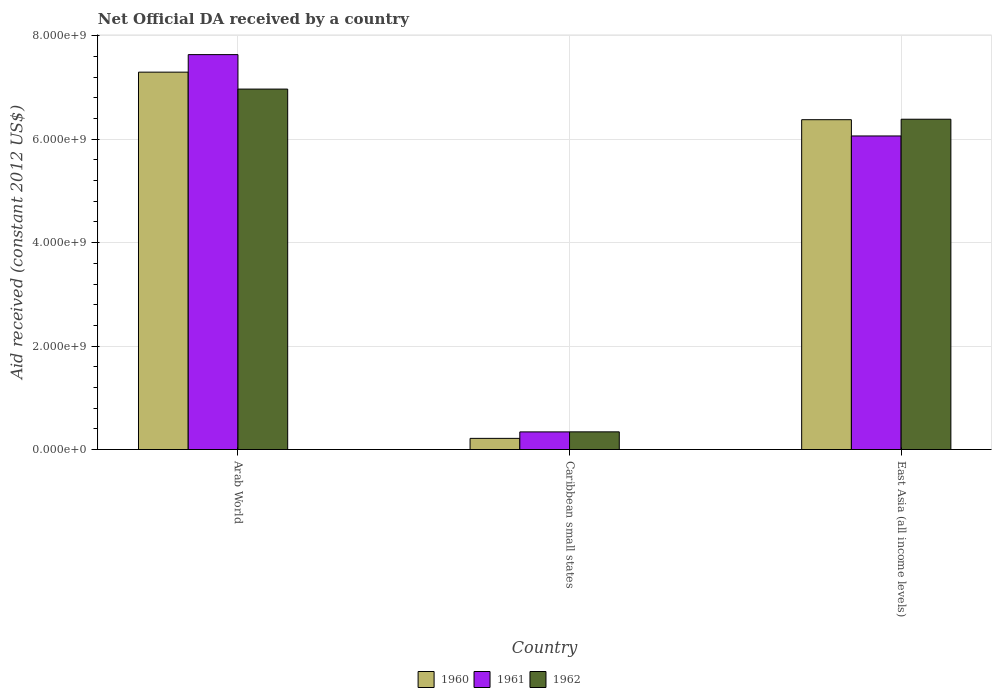How many different coloured bars are there?
Give a very brief answer. 3. Are the number of bars on each tick of the X-axis equal?
Offer a very short reply. Yes. How many bars are there on the 3rd tick from the left?
Provide a succinct answer. 3. How many bars are there on the 1st tick from the right?
Your answer should be very brief. 3. What is the label of the 3rd group of bars from the left?
Your answer should be compact. East Asia (all income levels). In how many cases, is the number of bars for a given country not equal to the number of legend labels?
Provide a succinct answer. 0. What is the net official development assistance aid received in 1960 in East Asia (all income levels)?
Your answer should be very brief. 6.38e+09. Across all countries, what is the maximum net official development assistance aid received in 1960?
Your answer should be very brief. 7.30e+09. Across all countries, what is the minimum net official development assistance aid received in 1960?
Offer a very short reply. 2.15e+08. In which country was the net official development assistance aid received in 1960 maximum?
Give a very brief answer. Arab World. In which country was the net official development assistance aid received in 1962 minimum?
Offer a very short reply. Caribbean small states. What is the total net official development assistance aid received in 1961 in the graph?
Provide a succinct answer. 1.40e+1. What is the difference between the net official development assistance aid received in 1962 in Caribbean small states and that in East Asia (all income levels)?
Your response must be concise. -6.04e+09. What is the difference between the net official development assistance aid received in 1960 in East Asia (all income levels) and the net official development assistance aid received in 1961 in Caribbean small states?
Make the answer very short. 6.04e+09. What is the average net official development assistance aid received in 1961 per country?
Keep it short and to the point. 4.68e+09. What is the difference between the net official development assistance aid received of/in 1961 and net official development assistance aid received of/in 1960 in East Asia (all income levels)?
Make the answer very short. -3.14e+08. What is the ratio of the net official development assistance aid received in 1962 in Caribbean small states to that in East Asia (all income levels)?
Your answer should be very brief. 0.05. Is the difference between the net official development assistance aid received in 1961 in Arab World and East Asia (all income levels) greater than the difference between the net official development assistance aid received in 1960 in Arab World and East Asia (all income levels)?
Ensure brevity in your answer.  Yes. What is the difference between the highest and the second highest net official development assistance aid received in 1961?
Give a very brief answer. 7.29e+09. What is the difference between the highest and the lowest net official development assistance aid received in 1960?
Give a very brief answer. 7.08e+09. Is the sum of the net official development assistance aid received in 1960 in Arab World and East Asia (all income levels) greater than the maximum net official development assistance aid received in 1961 across all countries?
Your response must be concise. Yes. What does the 3rd bar from the left in East Asia (all income levels) represents?
Offer a very short reply. 1962. What does the 2nd bar from the right in East Asia (all income levels) represents?
Offer a terse response. 1961. Is it the case that in every country, the sum of the net official development assistance aid received in 1962 and net official development assistance aid received in 1960 is greater than the net official development assistance aid received in 1961?
Offer a terse response. Yes. Are the values on the major ticks of Y-axis written in scientific E-notation?
Make the answer very short. Yes. Does the graph contain grids?
Keep it short and to the point. Yes. How many legend labels are there?
Keep it short and to the point. 3. How are the legend labels stacked?
Your response must be concise. Horizontal. What is the title of the graph?
Your answer should be compact. Net Official DA received by a country. What is the label or title of the Y-axis?
Offer a terse response. Aid received (constant 2012 US$). What is the Aid received (constant 2012 US$) of 1960 in Arab World?
Offer a very short reply. 7.30e+09. What is the Aid received (constant 2012 US$) of 1961 in Arab World?
Your answer should be very brief. 7.64e+09. What is the Aid received (constant 2012 US$) of 1962 in Arab World?
Ensure brevity in your answer.  6.97e+09. What is the Aid received (constant 2012 US$) of 1960 in Caribbean small states?
Offer a very short reply. 2.15e+08. What is the Aid received (constant 2012 US$) of 1961 in Caribbean small states?
Provide a succinct answer. 3.41e+08. What is the Aid received (constant 2012 US$) in 1962 in Caribbean small states?
Make the answer very short. 3.42e+08. What is the Aid received (constant 2012 US$) in 1960 in East Asia (all income levels)?
Your response must be concise. 6.38e+09. What is the Aid received (constant 2012 US$) of 1961 in East Asia (all income levels)?
Your response must be concise. 6.06e+09. What is the Aid received (constant 2012 US$) of 1962 in East Asia (all income levels)?
Provide a succinct answer. 6.39e+09. Across all countries, what is the maximum Aid received (constant 2012 US$) of 1960?
Offer a very short reply. 7.30e+09. Across all countries, what is the maximum Aid received (constant 2012 US$) of 1961?
Ensure brevity in your answer.  7.64e+09. Across all countries, what is the maximum Aid received (constant 2012 US$) of 1962?
Offer a terse response. 6.97e+09. Across all countries, what is the minimum Aid received (constant 2012 US$) in 1960?
Your answer should be very brief. 2.15e+08. Across all countries, what is the minimum Aid received (constant 2012 US$) of 1961?
Your response must be concise. 3.41e+08. Across all countries, what is the minimum Aid received (constant 2012 US$) in 1962?
Provide a succinct answer. 3.42e+08. What is the total Aid received (constant 2012 US$) of 1960 in the graph?
Offer a terse response. 1.39e+1. What is the total Aid received (constant 2012 US$) of 1961 in the graph?
Offer a terse response. 1.40e+1. What is the total Aid received (constant 2012 US$) in 1962 in the graph?
Ensure brevity in your answer.  1.37e+1. What is the difference between the Aid received (constant 2012 US$) in 1960 in Arab World and that in Caribbean small states?
Ensure brevity in your answer.  7.08e+09. What is the difference between the Aid received (constant 2012 US$) of 1961 in Arab World and that in Caribbean small states?
Provide a succinct answer. 7.29e+09. What is the difference between the Aid received (constant 2012 US$) in 1962 in Arab World and that in Caribbean small states?
Make the answer very short. 6.63e+09. What is the difference between the Aid received (constant 2012 US$) in 1960 in Arab World and that in East Asia (all income levels)?
Your answer should be very brief. 9.19e+08. What is the difference between the Aid received (constant 2012 US$) of 1961 in Arab World and that in East Asia (all income levels)?
Offer a terse response. 1.57e+09. What is the difference between the Aid received (constant 2012 US$) of 1962 in Arab World and that in East Asia (all income levels)?
Your response must be concise. 5.83e+08. What is the difference between the Aid received (constant 2012 US$) in 1960 in Caribbean small states and that in East Asia (all income levels)?
Ensure brevity in your answer.  -6.16e+09. What is the difference between the Aid received (constant 2012 US$) of 1961 in Caribbean small states and that in East Asia (all income levels)?
Give a very brief answer. -5.72e+09. What is the difference between the Aid received (constant 2012 US$) in 1962 in Caribbean small states and that in East Asia (all income levels)?
Ensure brevity in your answer.  -6.04e+09. What is the difference between the Aid received (constant 2012 US$) of 1960 in Arab World and the Aid received (constant 2012 US$) of 1961 in Caribbean small states?
Offer a terse response. 6.96e+09. What is the difference between the Aid received (constant 2012 US$) in 1960 in Arab World and the Aid received (constant 2012 US$) in 1962 in Caribbean small states?
Keep it short and to the point. 6.95e+09. What is the difference between the Aid received (constant 2012 US$) in 1961 in Arab World and the Aid received (constant 2012 US$) in 1962 in Caribbean small states?
Give a very brief answer. 7.29e+09. What is the difference between the Aid received (constant 2012 US$) of 1960 in Arab World and the Aid received (constant 2012 US$) of 1961 in East Asia (all income levels)?
Ensure brevity in your answer.  1.23e+09. What is the difference between the Aid received (constant 2012 US$) of 1960 in Arab World and the Aid received (constant 2012 US$) of 1962 in East Asia (all income levels)?
Your answer should be very brief. 9.10e+08. What is the difference between the Aid received (constant 2012 US$) in 1961 in Arab World and the Aid received (constant 2012 US$) in 1962 in East Asia (all income levels)?
Your response must be concise. 1.25e+09. What is the difference between the Aid received (constant 2012 US$) of 1960 in Caribbean small states and the Aid received (constant 2012 US$) of 1961 in East Asia (all income levels)?
Your response must be concise. -5.85e+09. What is the difference between the Aid received (constant 2012 US$) of 1960 in Caribbean small states and the Aid received (constant 2012 US$) of 1962 in East Asia (all income levels)?
Offer a terse response. -6.17e+09. What is the difference between the Aid received (constant 2012 US$) of 1961 in Caribbean small states and the Aid received (constant 2012 US$) of 1962 in East Asia (all income levels)?
Your answer should be very brief. -6.05e+09. What is the average Aid received (constant 2012 US$) of 1960 per country?
Your answer should be compact. 4.63e+09. What is the average Aid received (constant 2012 US$) in 1961 per country?
Make the answer very short. 4.68e+09. What is the average Aid received (constant 2012 US$) in 1962 per country?
Make the answer very short. 4.57e+09. What is the difference between the Aid received (constant 2012 US$) of 1960 and Aid received (constant 2012 US$) of 1961 in Arab World?
Provide a succinct answer. -3.39e+08. What is the difference between the Aid received (constant 2012 US$) in 1960 and Aid received (constant 2012 US$) in 1962 in Arab World?
Offer a very short reply. 3.27e+08. What is the difference between the Aid received (constant 2012 US$) in 1961 and Aid received (constant 2012 US$) in 1962 in Arab World?
Offer a very short reply. 6.66e+08. What is the difference between the Aid received (constant 2012 US$) of 1960 and Aid received (constant 2012 US$) of 1961 in Caribbean small states?
Your answer should be compact. -1.25e+08. What is the difference between the Aid received (constant 2012 US$) of 1960 and Aid received (constant 2012 US$) of 1962 in Caribbean small states?
Your response must be concise. -1.26e+08. What is the difference between the Aid received (constant 2012 US$) in 1961 and Aid received (constant 2012 US$) in 1962 in Caribbean small states?
Your answer should be compact. -7.40e+05. What is the difference between the Aid received (constant 2012 US$) of 1960 and Aid received (constant 2012 US$) of 1961 in East Asia (all income levels)?
Offer a terse response. 3.14e+08. What is the difference between the Aid received (constant 2012 US$) of 1960 and Aid received (constant 2012 US$) of 1962 in East Asia (all income levels)?
Offer a terse response. -9.20e+06. What is the difference between the Aid received (constant 2012 US$) in 1961 and Aid received (constant 2012 US$) in 1962 in East Asia (all income levels)?
Your response must be concise. -3.24e+08. What is the ratio of the Aid received (constant 2012 US$) of 1960 in Arab World to that in Caribbean small states?
Your answer should be compact. 33.86. What is the ratio of the Aid received (constant 2012 US$) in 1961 in Arab World to that in Caribbean small states?
Offer a very short reply. 22.4. What is the ratio of the Aid received (constant 2012 US$) in 1962 in Arab World to that in Caribbean small states?
Your answer should be compact. 20.4. What is the ratio of the Aid received (constant 2012 US$) in 1960 in Arab World to that in East Asia (all income levels)?
Provide a short and direct response. 1.14. What is the ratio of the Aid received (constant 2012 US$) of 1961 in Arab World to that in East Asia (all income levels)?
Provide a short and direct response. 1.26. What is the ratio of the Aid received (constant 2012 US$) of 1962 in Arab World to that in East Asia (all income levels)?
Provide a succinct answer. 1.09. What is the ratio of the Aid received (constant 2012 US$) in 1960 in Caribbean small states to that in East Asia (all income levels)?
Your response must be concise. 0.03. What is the ratio of the Aid received (constant 2012 US$) in 1961 in Caribbean small states to that in East Asia (all income levels)?
Your response must be concise. 0.06. What is the ratio of the Aid received (constant 2012 US$) of 1962 in Caribbean small states to that in East Asia (all income levels)?
Offer a terse response. 0.05. What is the difference between the highest and the second highest Aid received (constant 2012 US$) in 1960?
Your response must be concise. 9.19e+08. What is the difference between the highest and the second highest Aid received (constant 2012 US$) in 1961?
Offer a very short reply. 1.57e+09. What is the difference between the highest and the second highest Aid received (constant 2012 US$) of 1962?
Keep it short and to the point. 5.83e+08. What is the difference between the highest and the lowest Aid received (constant 2012 US$) in 1960?
Offer a very short reply. 7.08e+09. What is the difference between the highest and the lowest Aid received (constant 2012 US$) of 1961?
Offer a terse response. 7.29e+09. What is the difference between the highest and the lowest Aid received (constant 2012 US$) of 1962?
Provide a short and direct response. 6.63e+09. 